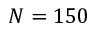Convert formula to latex. <formula><loc_0><loc_0><loc_500><loc_500>N = 1 5 0</formula> 